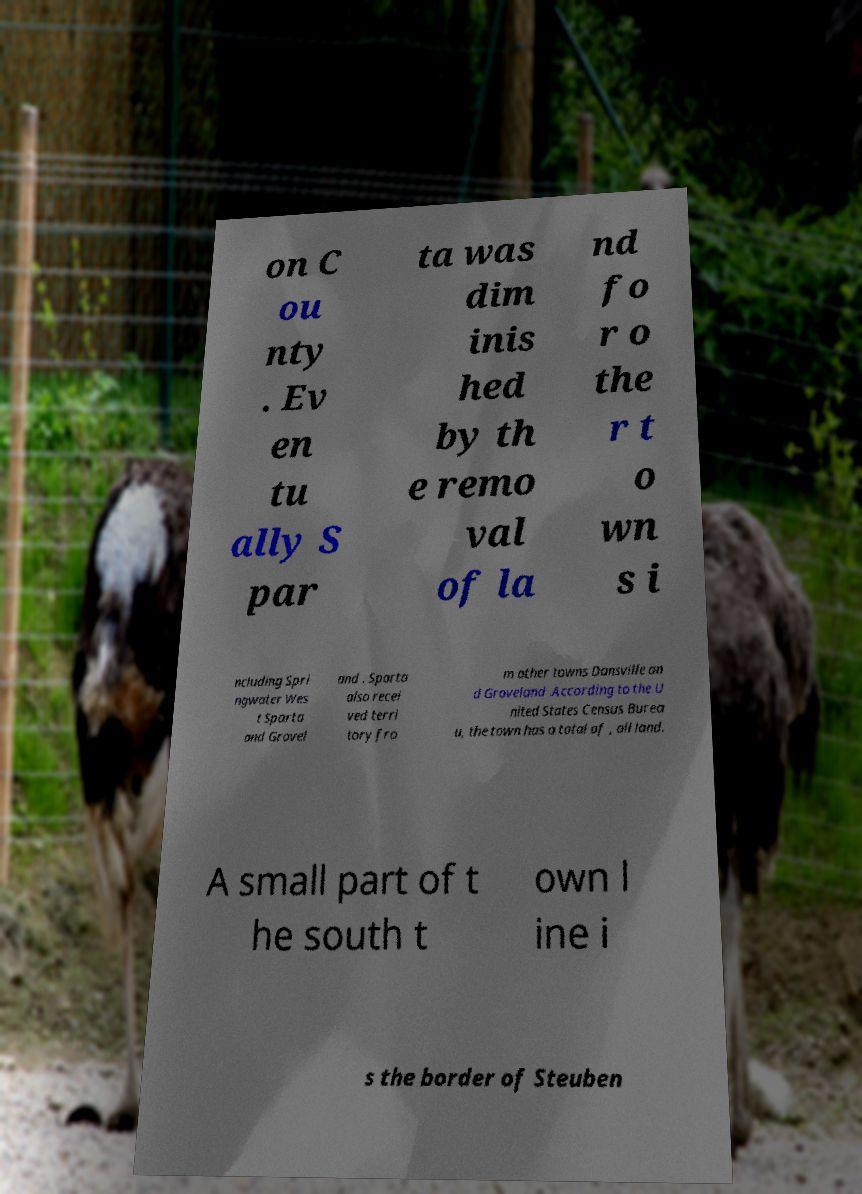I need the written content from this picture converted into text. Can you do that? on C ou nty . Ev en tu ally S par ta was dim inis hed by th e remo val of la nd fo r o the r t o wn s i ncluding Spri ngwater Wes t Sparta and Grovel and . Sparta also recei ved terri tory fro m other towns Dansville an d Groveland .According to the U nited States Census Burea u, the town has a total of , all land. A small part of t he south t own l ine i s the border of Steuben 